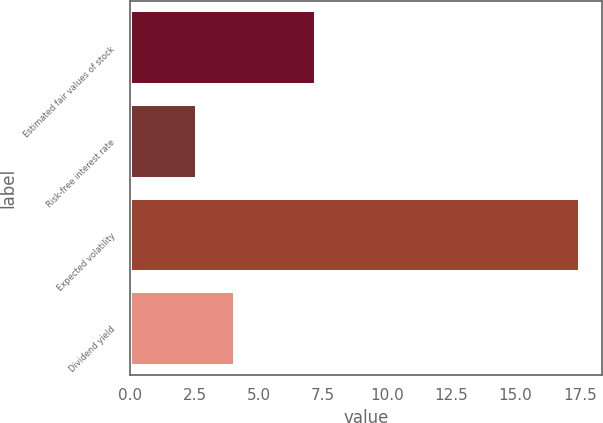Convert chart to OTSL. <chart><loc_0><loc_0><loc_500><loc_500><bar_chart><fcel>Estimated fair values of stock<fcel>Risk-free interest rate<fcel>Expected volatility<fcel>Dividend yield<nl><fcel>7.22<fcel>2.6<fcel>17.5<fcel>4.09<nl></chart> 